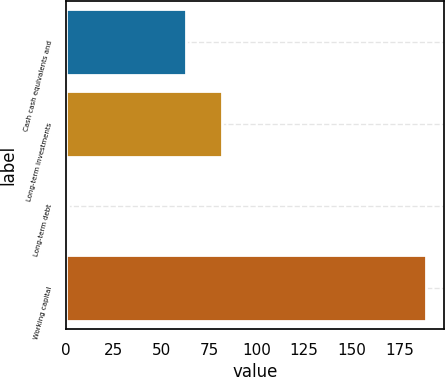<chart> <loc_0><loc_0><loc_500><loc_500><bar_chart><fcel>Cash cash equivalents and<fcel>Long-term investments<fcel>Long-term debt<fcel>Working capital<nl><fcel>63<fcel>81.79<fcel>1.08<fcel>189<nl></chart> 